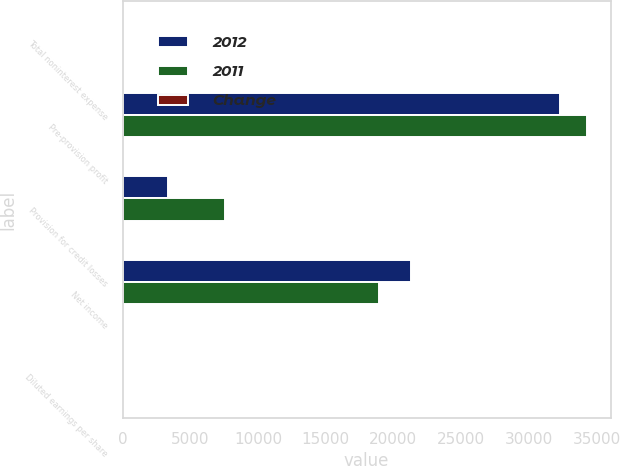Convert chart. <chart><loc_0><loc_0><loc_500><loc_500><stacked_bar_chart><ecel><fcel>Total noninterest expense<fcel>Pre-provision profit<fcel>Provision for credit losses<fcel>Net income<fcel>Diluted earnings per share<nl><fcel>2012<fcel>55<fcel>32302<fcel>3385<fcel>21284<fcel>5.2<nl><fcel>2011<fcel>55<fcel>34323<fcel>7574<fcel>18976<fcel>4.48<nl><fcel>Change<fcel>3<fcel>6<fcel>55<fcel>12<fcel>16<nl></chart> 